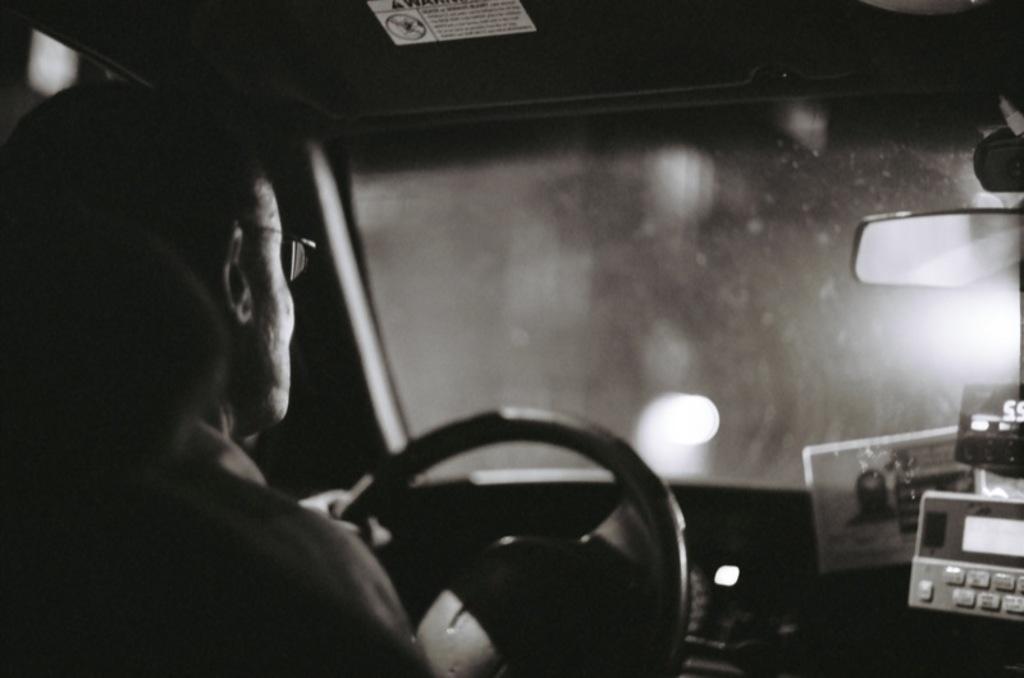Could you give a brief overview of what you see in this image? This is a black and white image, in this image there is a man sitting inside a car. 